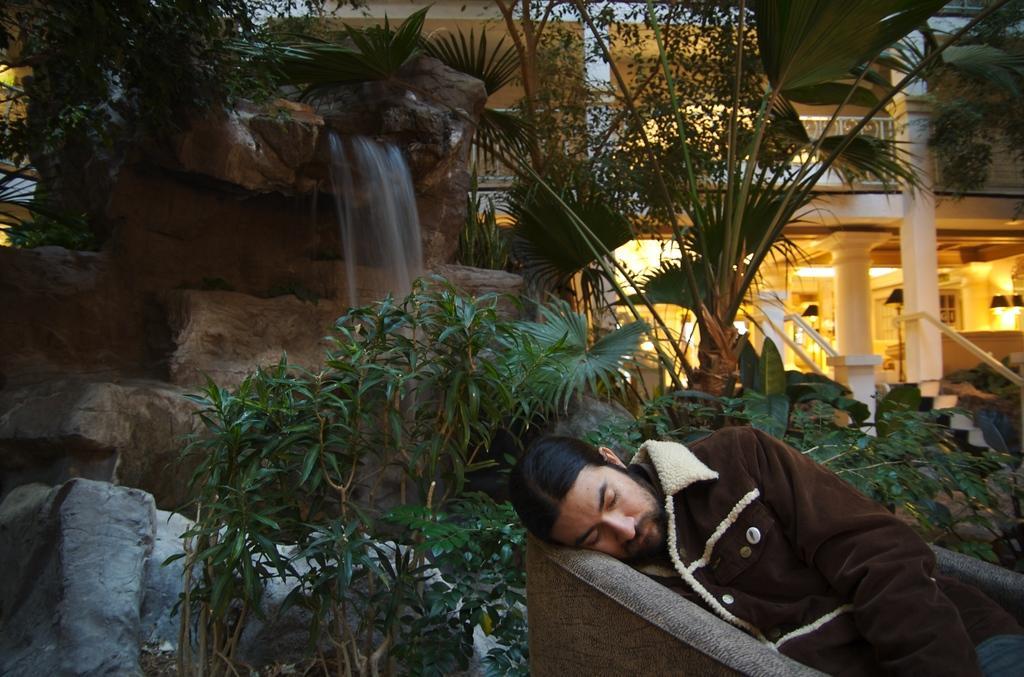How would you summarize this image in a sentence or two? As we can see in the image there are plants, trees, water, rocks and buildings. In the front there is a man sleeping on sofa. 